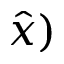Convert formula to latex. <formula><loc_0><loc_0><loc_500><loc_500>\hat { x } )</formula> 